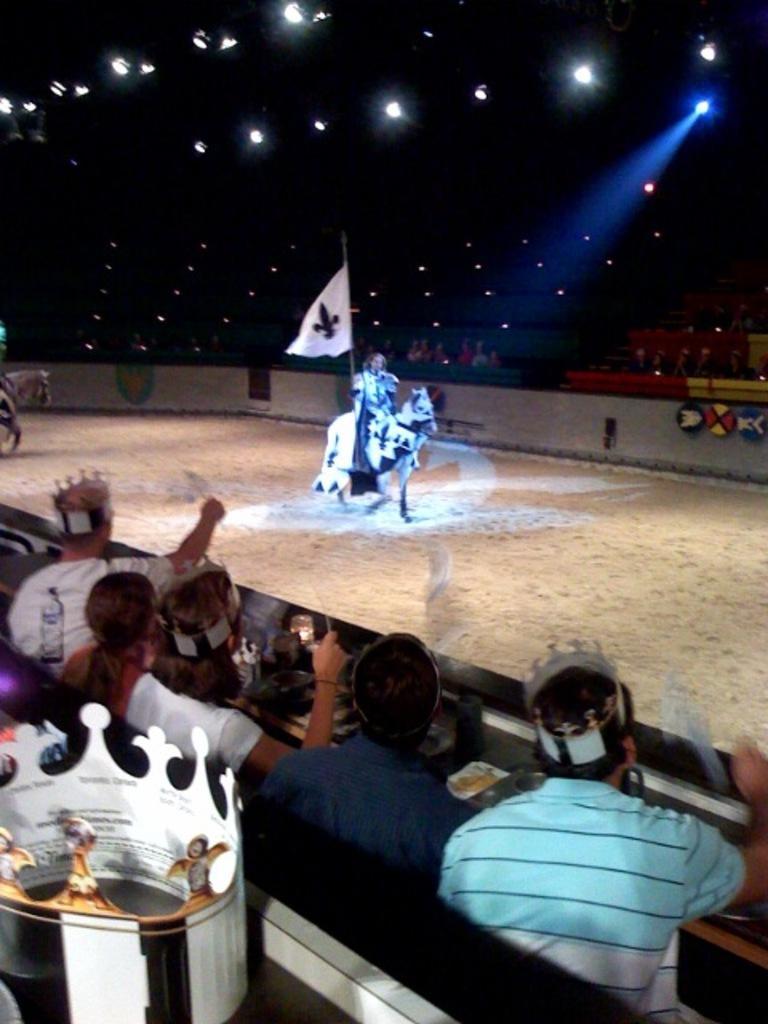Describe this image in one or two sentences. In this image at the center people are sitting on the horse by holding the flag. On both right and left side of the image people are sitting on the chairs. In front of the people there is a table and on top of the table there are few objects. On top of the roof there are lights. 